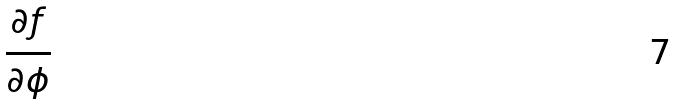<formula> <loc_0><loc_0><loc_500><loc_500>\frac { \partial f } { \partial \phi }</formula> 